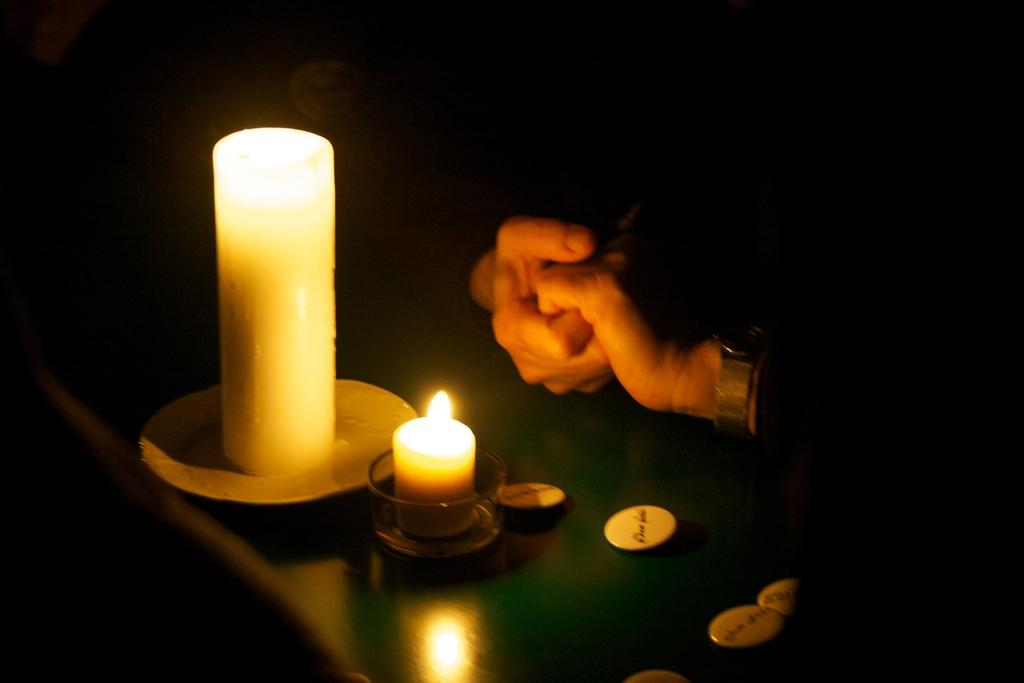What objects are on the table in the image? There are two candle lights on a green color table. Where is the table located in the image? The table is on the left side of the image. What can be seen in the background of the image? There are two persons in the background, and they are holding hands. How would you describe the background's color? The background is dark in color. What type of silver material is present on the table in the image? There is no silver material present on the table in the image; the table is green in color. What adjustment can be made to the shape of the candle lights in the image? The candle lights in the image are not adjustable, as they are stationary objects. 